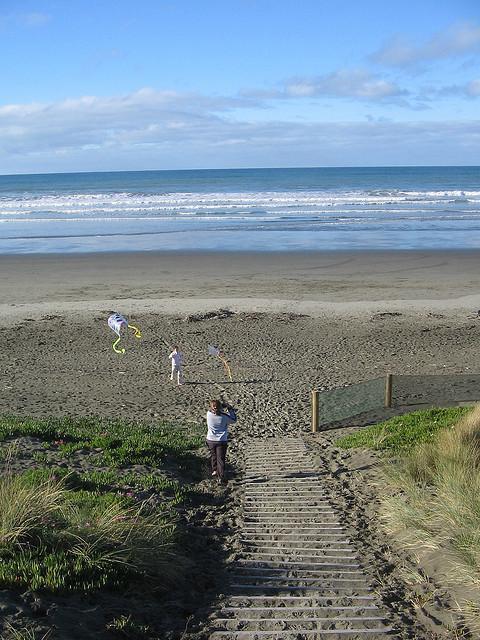How many kites are there in this picture?
Give a very brief answer. 2. 